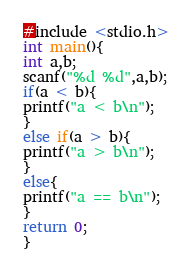Convert code to text. <code><loc_0><loc_0><loc_500><loc_500><_C#_>#include <stdio.h>
int main(){
int a,b;
scanf("%d %d",a,b);
if(a < b){
printf("a < b\n");
}
else if(a > b){
printf("a > b\n");
}
else{
printf("a == b\n");
}
return 0;
}</code> 